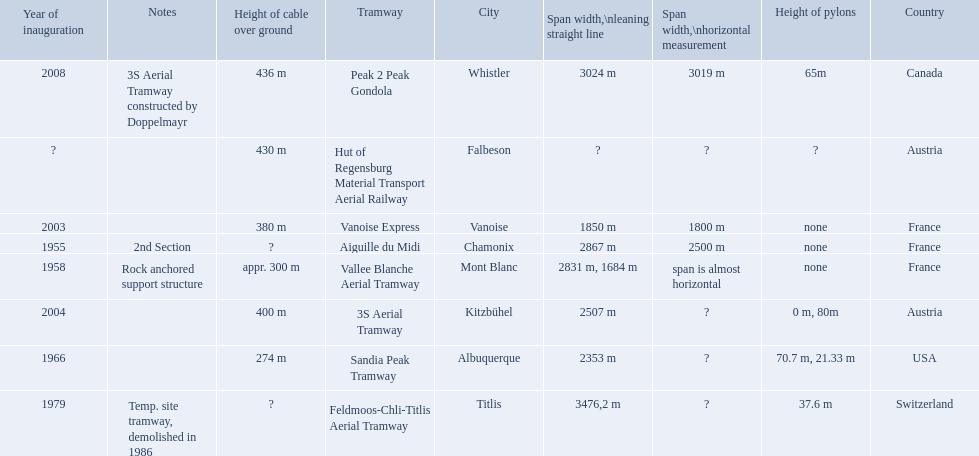What are all of the tramways? Peak 2 Peak Gondola, Hut of Regensburg Material Transport Aerial Railway, Vanoise Express, Aiguille du Midi, Vallee Blanche Aerial Tramway, 3S Aerial Tramway, Sandia Peak Tramway, Feldmoos-Chli-Titlis Aerial Tramway. When were they inaugurated? 2008, ?, 2003, 1955, 1958, 2004, 1966, 1979. Now, between 3s aerial tramway and aiguille du midi, which was inaugurated first? Aiguille du Midi. 